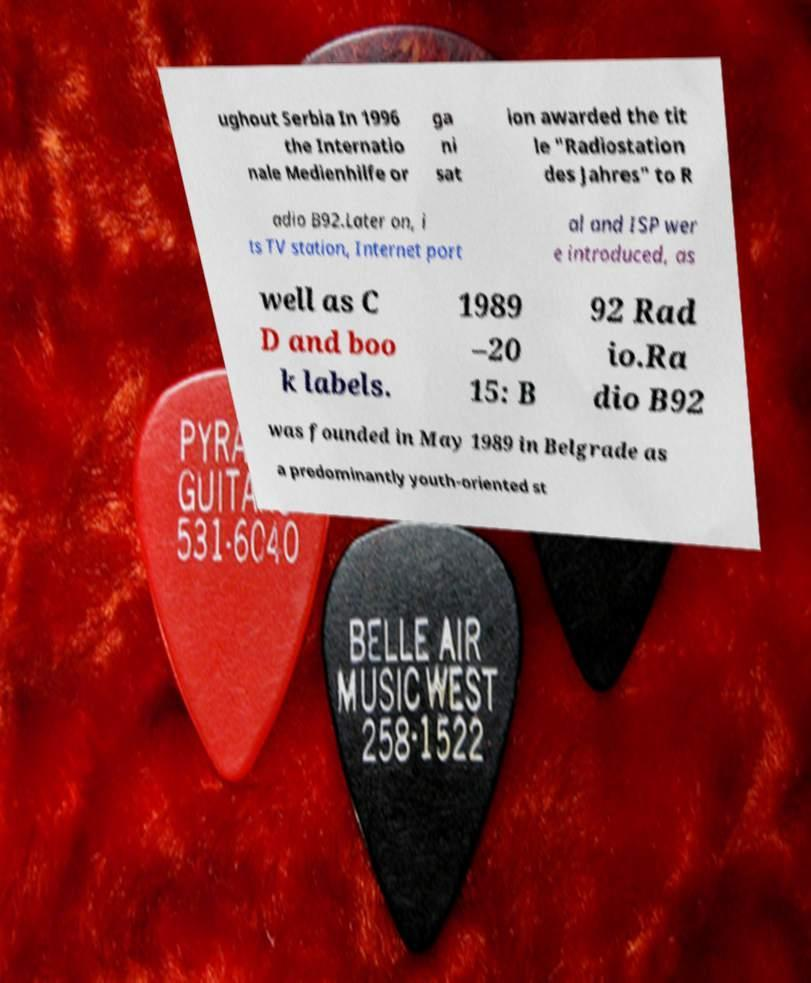There's text embedded in this image that I need extracted. Can you transcribe it verbatim? ughout Serbia In 1996 the Internatio nale Medienhilfe or ga ni sat ion awarded the tit le "Radiostation des Jahres" to R adio B92.Later on, i ts TV station, Internet port al and ISP wer e introduced, as well as C D and boo k labels. 1989 –20 15: B 92 Rad io.Ra dio B92 was founded in May 1989 in Belgrade as a predominantly youth-oriented st 